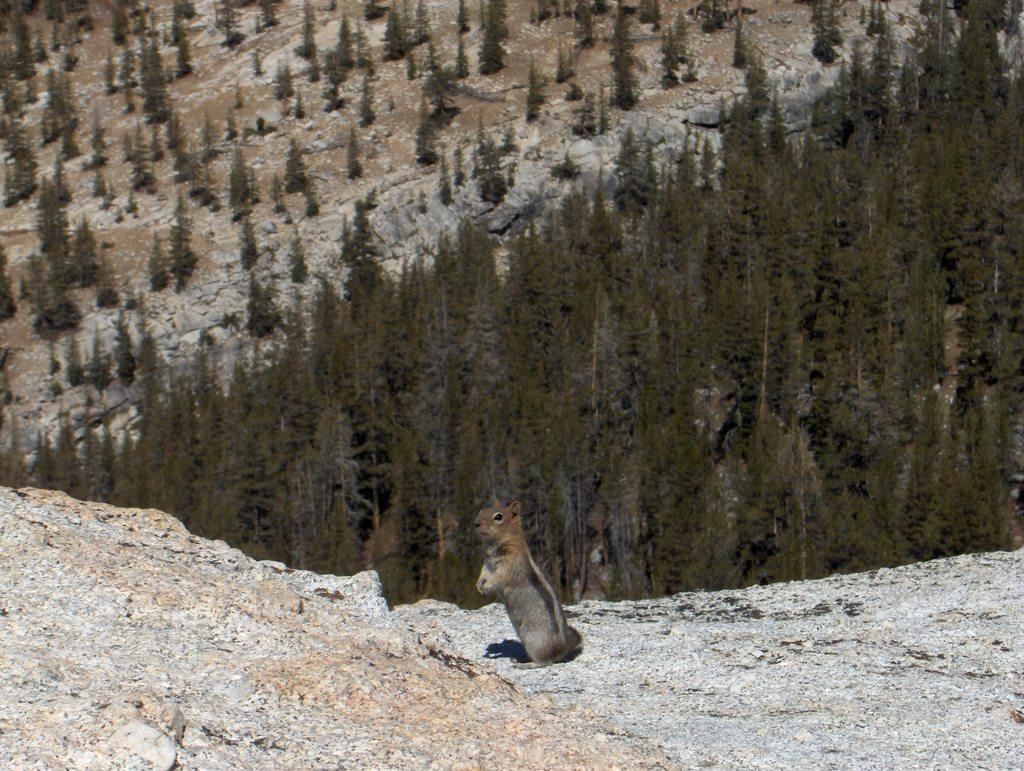How would you summarize this image in a sentence or two? In this image in the center there is one squirrel, at the bottom there is some sand and in the background there are some trees and mountains. 